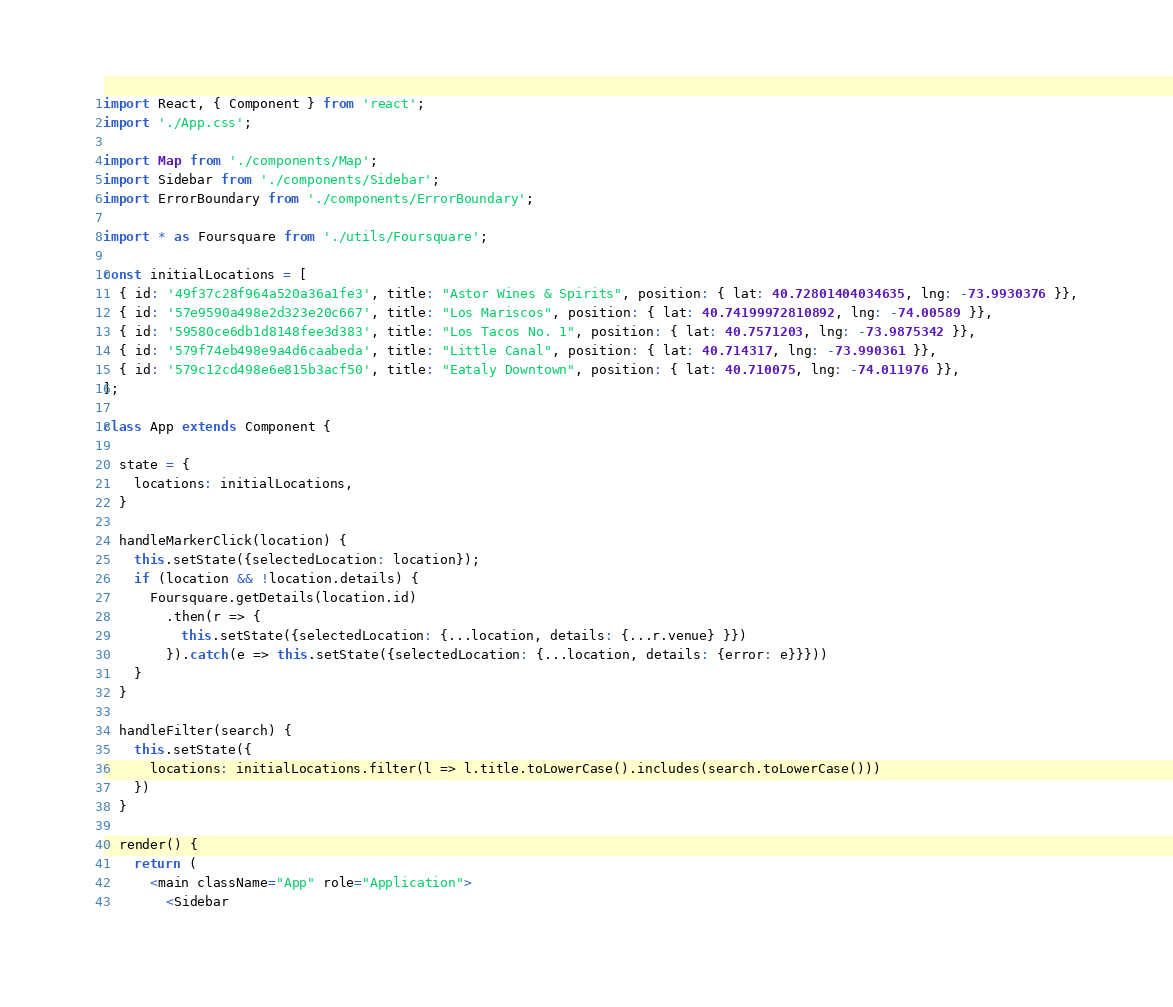<code> <loc_0><loc_0><loc_500><loc_500><_JavaScript_>import React, { Component } from 'react';
import './App.css';

import Map from './components/Map';
import Sidebar from './components/Sidebar';
import ErrorBoundary from './components/ErrorBoundary';

import * as Foursquare from './utils/Foursquare';

const initialLocations = [
  { id: '49f37c28f964a520a36a1fe3', title: "Astor Wines & Spirits", position: { lat: 40.72801404034635, lng: -73.9930376 }},
  { id: '57e9590a498e2d323e20c667', title: "Los Mariscos", position: { lat: 40.74199972810892, lng: -74.00589 }},
  { id: '59580ce6db1d8148fee3d383', title: "Los Tacos No. 1", position: { lat: 40.7571203, lng: -73.9875342 }},
  { id: '579f74eb498e9a4d6caabeda', title: "Little Canal", position: { lat: 40.714317, lng: -73.990361 }},
  { id: '579c12cd498e6e815b3acf50', title: "Eataly Downtown", position: { lat: 40.710075, lng: -74.011976 }},
];

class App extends Component {

  state = {
    locations: initialLocations,
  }

  handleMarkerClick(location) {
    this.setState({selectedLocation: location});
    if (location && !location.details) {
      Foursquare.getDetails(location.id)
        .then(r => {
          this.setState({selectedLocation: {...location, details: {...r.venue} }})
        }).catch(e => this.setState({selectedLocation: {...location, details: {error: e}}}))
    }
  }

  handleFilter(search) {
    this.setState({
      locations: initialLocations.filter(l => l.title.toLowerCase().includes(search.toLowerCase()))
    })
  }

  render() {
    return (
      <main className="App" role="Application">
        <Sidebar</code> 